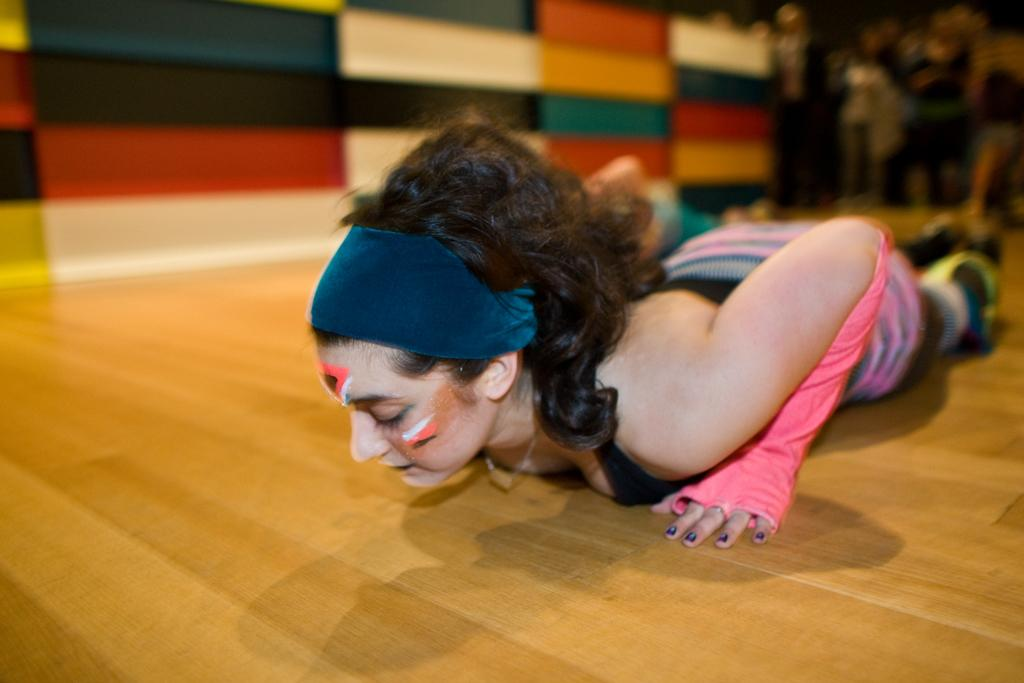Who is the main subject in the image? There is a lady in the image. What is the lady wearing on her head? The lady is wearing a headband. What type of clothing is the lady wearing on her hands? The lady is wearing gloves. What is the lady's position in the image? The lady is lying on the floor. How would you describe the background of the image? The background of the image is blurred. Can you see a cactus in the background of the image? There is no cactus present in the image; the background is blurred. 